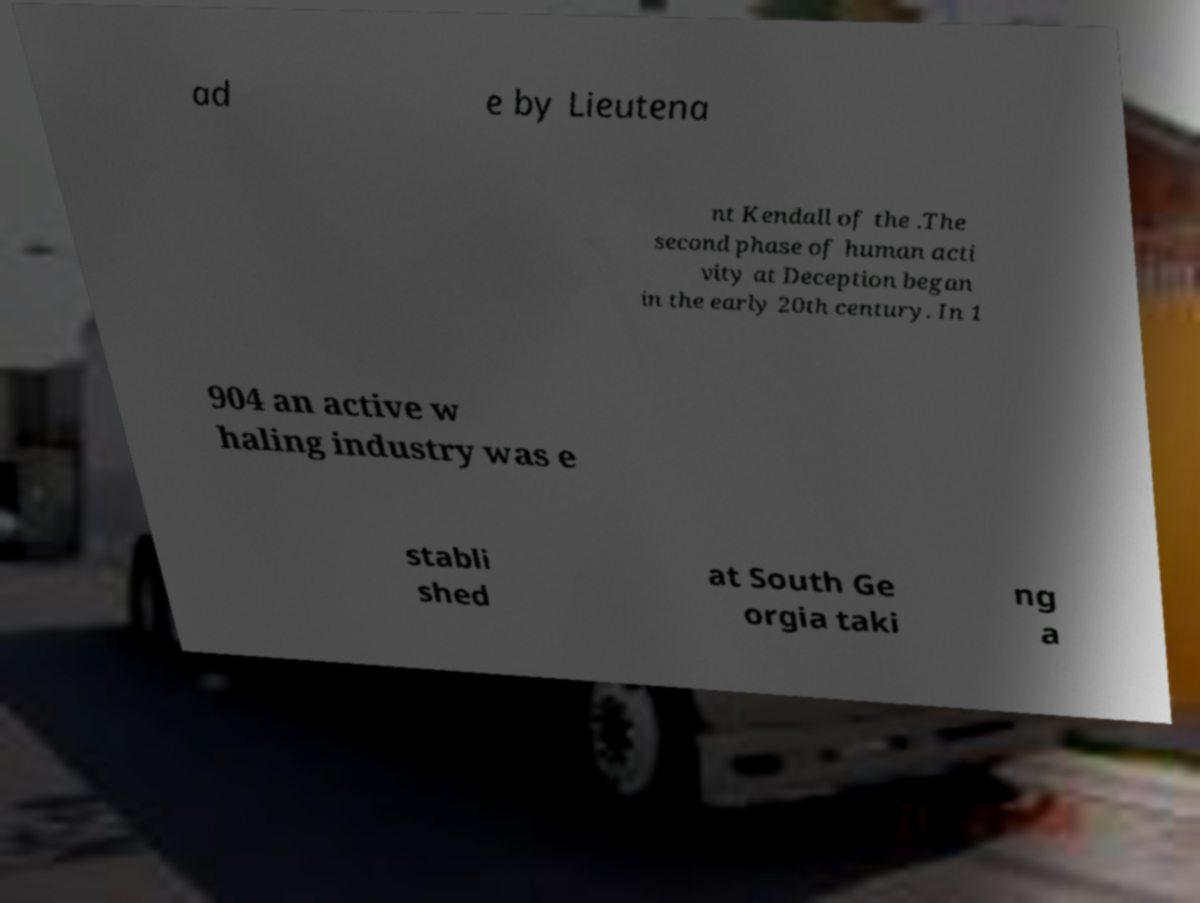Can you read and provide the text displayed in the image?This photo seems to have some interesting text. Can you extract and type it out for me? ad e by Lieutena nt Kendall of the .The second phase of human acti vity at Deception began in the early 20th century. In 1 904 an active w haling industry was e stabli shed at South Ge orgia taki ng a 